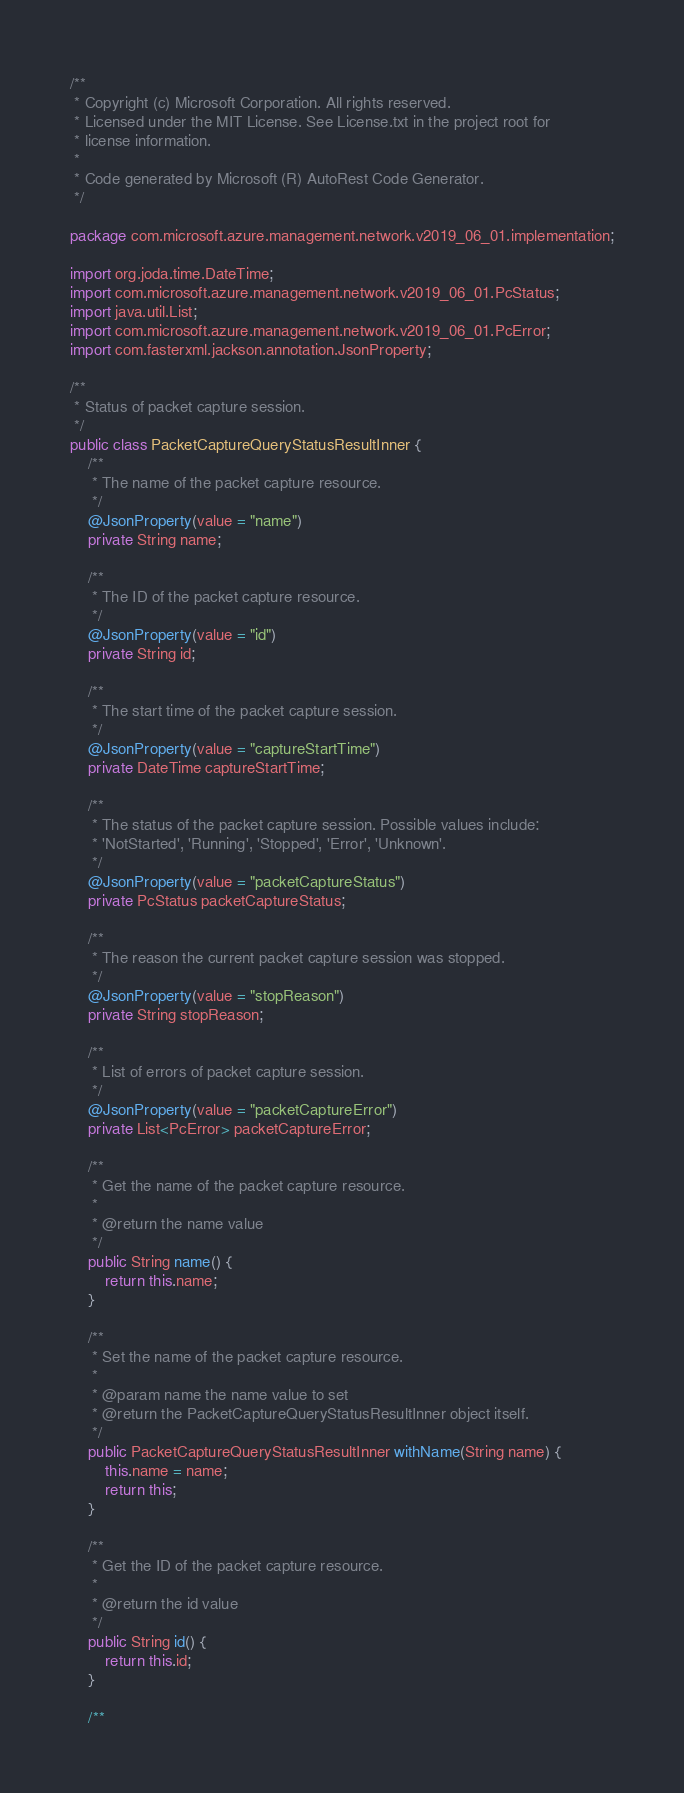Convert code to text. <code><loc_0><loc_0><loc_500><loc_500><_Java_>/**
 * Copyright (c) Microsoft Corporation. All rights reserved.
 * Licensed under the MIT License. See License.txt in the project root for
 * license information.
 *
 * Code generated by Microsoft (R) AutoRest Code Generator.
 */

package com.microsoft.azure.management.network.v2019_06_01.implementation;

import org.joda.time.DateTime;
import com.microsoft.azure.management.network.v2019_06_01.PcStatus;
import java.util.List;
import com.microsoft.azure.management.network.v2019_06_01.PcError;
import com.fasterxml.jackson.annotation.JsonProperty;

/**
 * Status of packet capture session.
 */
public class PacketCaptureQueryStatusResultInner {
    /**
     * The name of the packet capture resource.
     */
    @JsonProperty(value = "name")
    private String name;

    /**
     * The ID of the packet capture resource.
     */
    @JsonProperty(value = "id")
    private String id;

    /**
     * The start time of the packet capture session.
     */
    @JsonProperty(value = "captureStartTime")
    private DateTime captureStartTime;

    /**
     * The status of the packet capture session. Possible values include:
     * 'NotStarted', 'Running', 'Stopped', 'Error', 'Unknown'.
     */
    @JsonProperty(value = "packetCaptureStatus")
    private PcStatus packetCaptureStatus;

    /**
     * The reason the current packet capture session was stopped.
     */
    @JsonProperty(value = "stopReason")
    private String stopReason;

    /**
     * List of errors of packet capture session.
     */
    @JsonProperty(value = "packetCaptureError")
    private List<PcError> packetCaptureError;

    /**
     * Get the name of the packet capture resource.
     *
     * @return the name value
     */
    public String name() {
        return this.name;
    }

    /**
     * Set the name of the packet capture resource.
     *
     * @param name the name value to set
     * @return the PacketCaptureQueryStatusResultInner object itself.
     */
    public PacketCaptureQueryStatusResultInner withName(String name) {
        this.name = name;
        return this;
    }

    /**
     * Get the ID of the packet capture resource.
     *
     * @return the id value
     */
    public String id() {
        return this.id;
    }

    /**</code> 